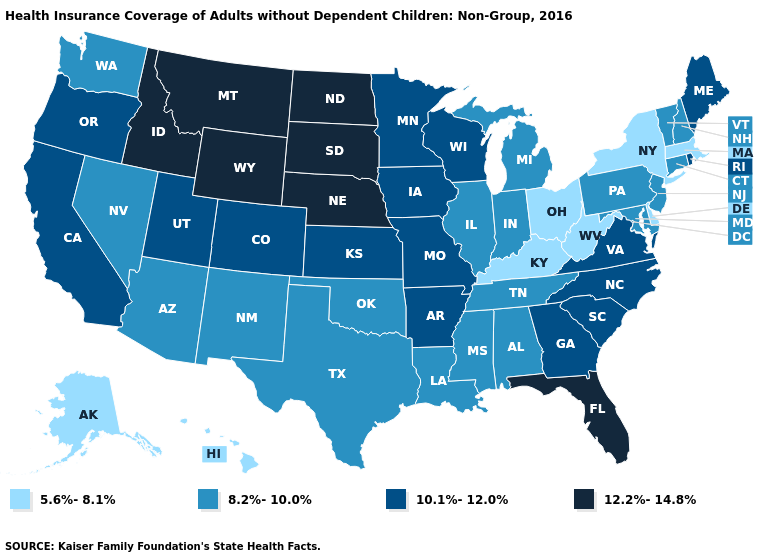Which states have the highest value in the USA?
Write a very short answer. Florida, Idaho, Montana, Nebraska, North Dakota, South Dakota, Wyoming. What is the value of Utah?
Be succinct. 10.1%-12.0%. Does Alaska have the lowest value in the West?
Keep it brief. Yes. Among the states that border Minnesota , does Iowa have the highest value?
Give a very brief answer. No. What is the lowest value in the Northeast?
Write a very short answer. 5.6%-8.1%. What is the value of Wyoming?
Give a very brief answer. 12.2%-14.8%. What is the value of Alaska?
Concise answer only. 5.6%-8.1%. What is the value of Mississippi?
Write a very short answer. 8.2%-10.0%. What is the value of Kansas?
Give a very brief answer. 10.1%-12.0%. Among the states that border Colorado , which have the highest value?
Concise answer only. Nebraska, Wyoming. Among the states that border Ohio , which have the highest value?
Quick response, please. Indiana, Michigan, Pennsylvania. Among the states that border Colorado , does Arizona have the highest value?
Quick response, please. No. Does Alabama have the lowest value in the USA?
Short answer required. No. 